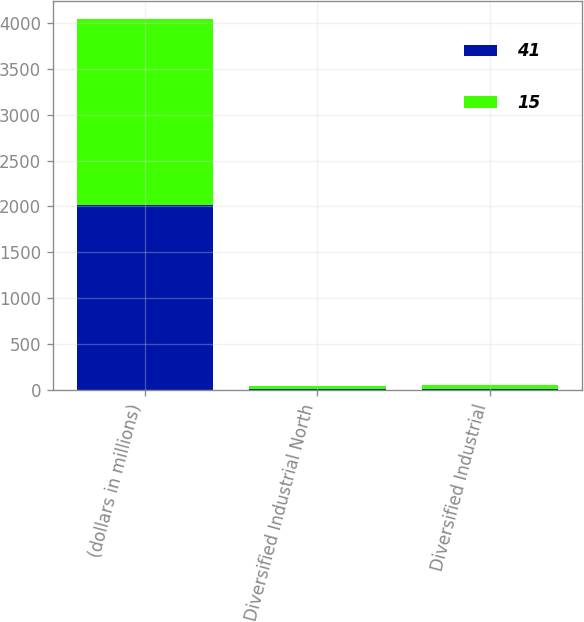Convert chart to OTSL. <chart><loc_0><loc_0><loc_500><loc_500><stacked_bar_chart><ecel><fcel>(dollars in millions)<fcel>Diversified Industrial North<fcel>Diversified Industrial<nl><fcel>41<fcel>2019<fcel>13<fcel>15<nl><fcel>15<fcel>2018<fcel>37<fcel>41<nl></chart> 